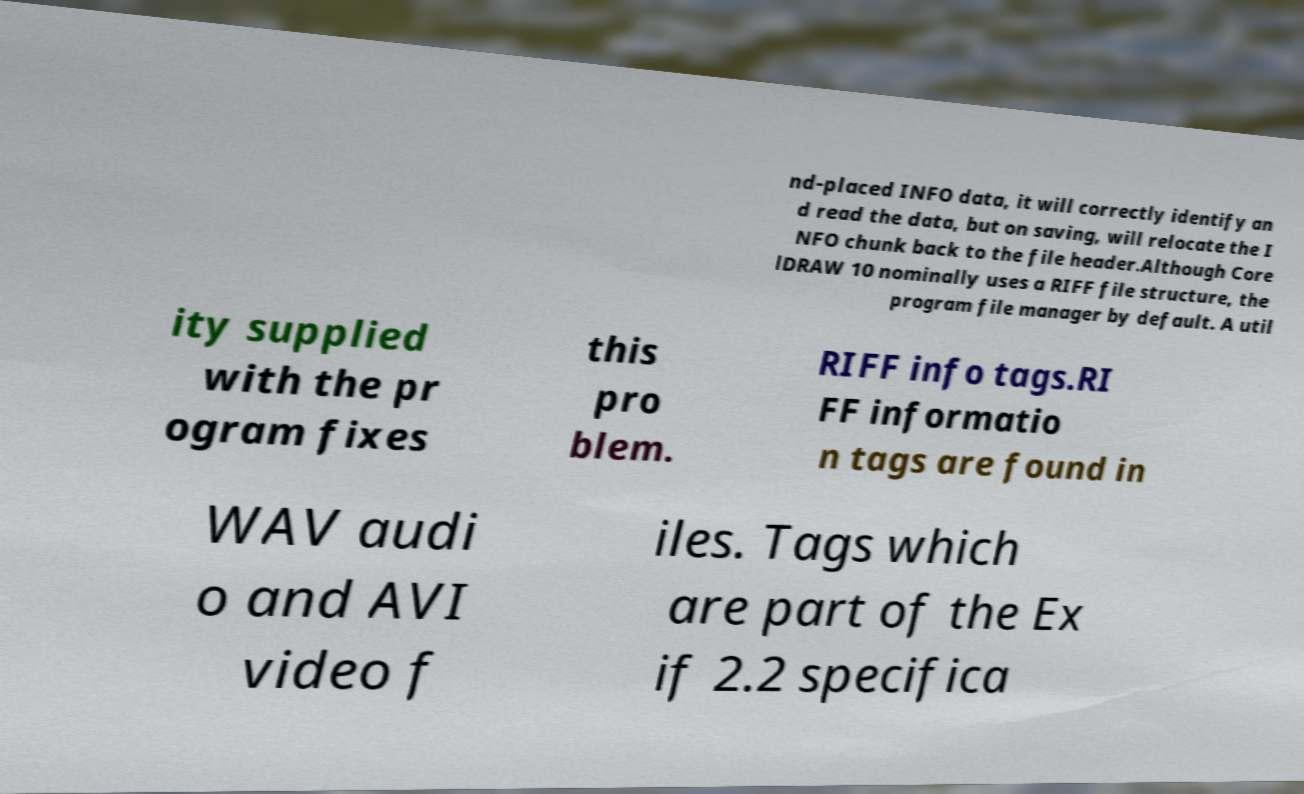Can you accurately transcribe the text from the provided image for me? nd-placed INFO data, it will correctly identify an d read the data, but on saving, will relocate the I NFO chunk back to the file header.Although Core lDRAW 10 nominally uses a RIFF file structure, the program file manager by default. A util ity supplied with the pr ogram fixes this pro blem. RIFF info tags.RI FF informatio n tags are found in WAV audi o and AVI video f iles. Tags which are part of the Ex if 2.2 specifica 